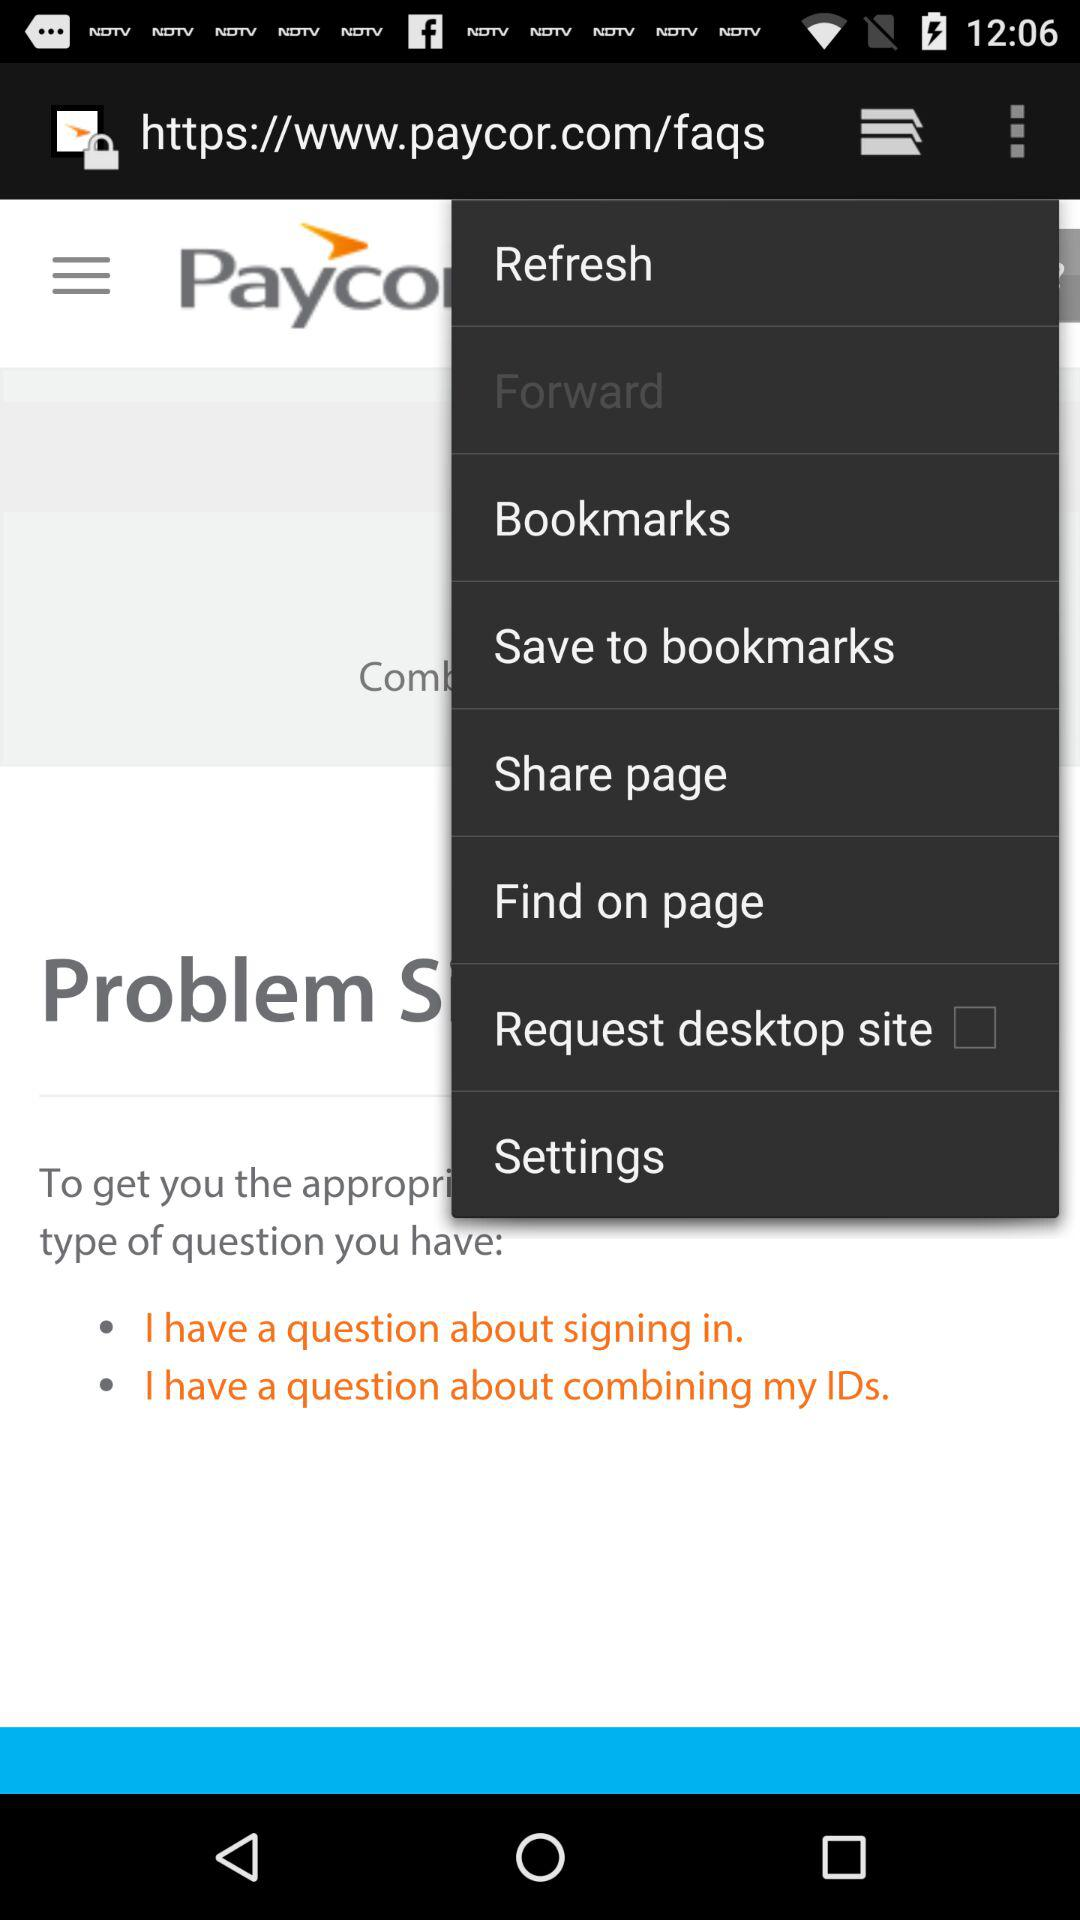What is the name of the application? The name of the application is "paycor". 